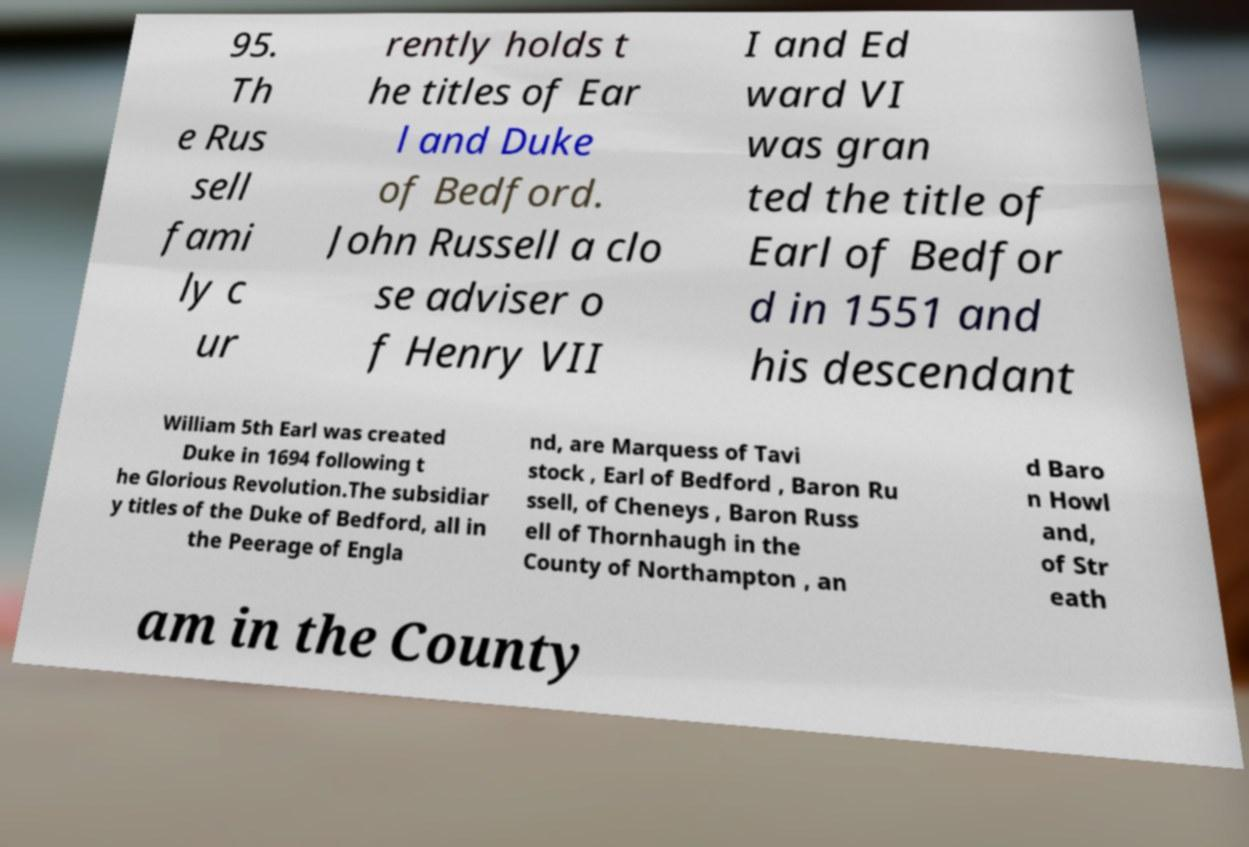Can you read and provide the text displayed in the image?This photo seems to have some interesting text. Can you extract and type it out for me? 95. Th e Rus sell fami ly c ur rently holds t he titles of Ear l and Duke of Bedford. John Russell a clo se adviser o f Henry VII I and Ed ward VI was gran ted the title of Earl of Bedfor d in 1551 and his descendant William 5th Earl was created Duke in 1694 following t he Glorious Revolution.The subsidiar y titles of the Duke of Bedford, all in the Peerage of Engla nd, are Marquess of Tavi stock , Earl of Bedford , Baron Ru ssell, of Cheneys , Baron Russ ell of Thornhaugh in the County of Northampton , an d Baro n Howl and, of Str eath am in the County 